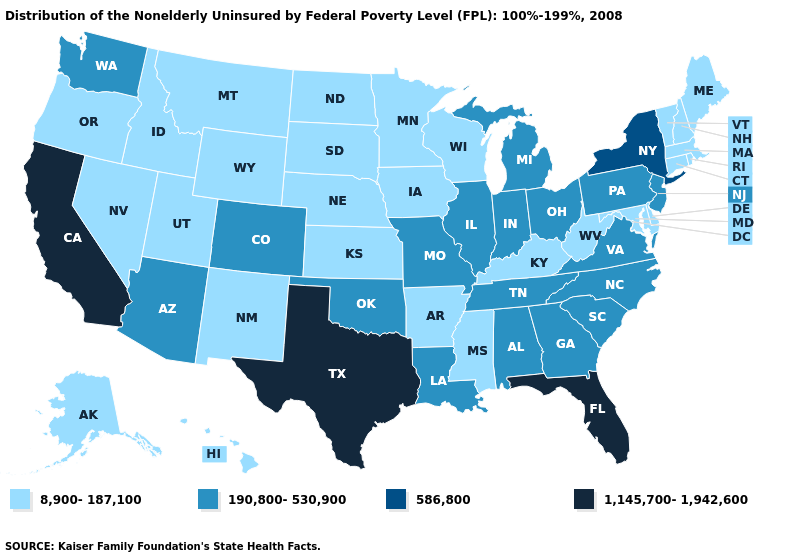Does Maine have the lowest value in the Northeast?
Answer briefly. Yes. Name the states that have a value in the range 586,800?
Short answer required. New York. What is the highest value in the USA?
Be succinct. 1,145,700-1,942,600. Name the states that have a value in the range 190,800-530,900?
Answer briefly. Alabama, Arizona, Colorado, Georgia, Illinois, Indiana, Louisiana, Michigan, Missouri, New Jersey, North Carolina, Ohio, Oklahoma, Pennsylvania, South Carolina, Tennessee, Virginia, Washington. Name the states that have a value in the range 8,900-187,100?
Be succinct. Alaska, Arkansas, Connecticut, Delaware, Hawaii, Idaho, Iowa, Kansas, Kentucky, Maine, Maryland, Massachusetts, Minnesota, Mississippi, Montana, Nebraska, Nevada, New Hampshire, New Mexico, North Dakota, Oregon, Rhode Island, South Dakota, Utah, Vermont, West Virginia, Wisconsin, Wyoming. What is the highest value in the USA?
Be succinct. 1,145,700-1,942,600. What is the value of New York?
Give a very brief answer. 586,800. Does West Virginia have a lower value than Alaska?
Answer briefly. No. What is the lowest value in states that border Iowa?
Answer briefly. 8,900-187,100. Name the states that have a value in the range 586,800?
Be succinct. New York. Name the states that have a value in the range 586,800?
Quick response, please. New York. What is the value of Texas?
Answer briefly. 1,145,700-1,942,600. Among the states that border Pennsylvania , does Maryland have the highest value?
Keep it brief. No. Is the legend a continuous bar?
Answer briefly. No. 